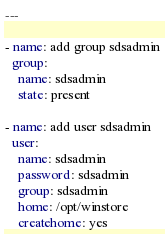<code> <loc_0><loc_0><loc_500><loc_500><_YAML_>---

- name: add group sdsadmin
  group: 
    name: sdsadmin
    state: present

- name: add user sdsadmin
  user: 
    name: sdsadmin
    password: sdsadmin
    group: sdsadmin
    home: /opt/winstore
    createhome: yes
</code> 